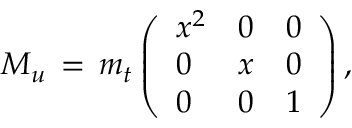Convert formula to latex. <formula><loc_0><loc_0><loc_500><loc_500>M _ { u } \, = \, m _ { t } \left ( \begin{array} { l l l } { { x ^ { 2 } } } & { 0 } & { 0 } \\ { 0 } & { x } & { 0 } \\ { 0 } & { 0 } & { 1 } \end{array} \right ) ,</formula> 